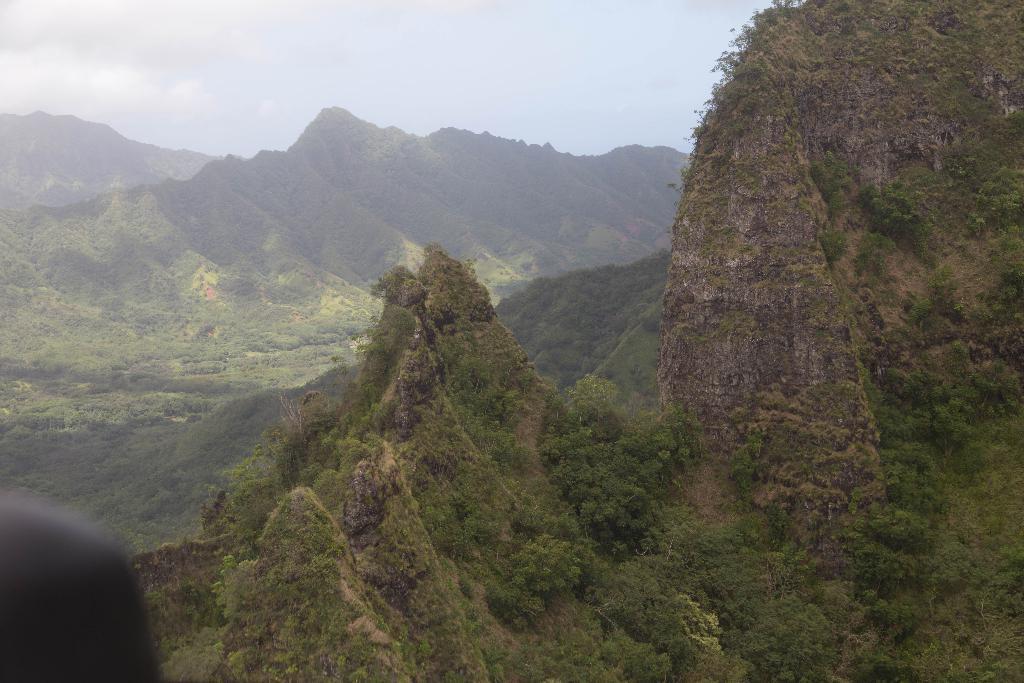Describe this image in one or two sentences. In this image I can see mountains, number of trees, clouds and the sky. I can also see a black colour thing on the bottom left side of this image. 